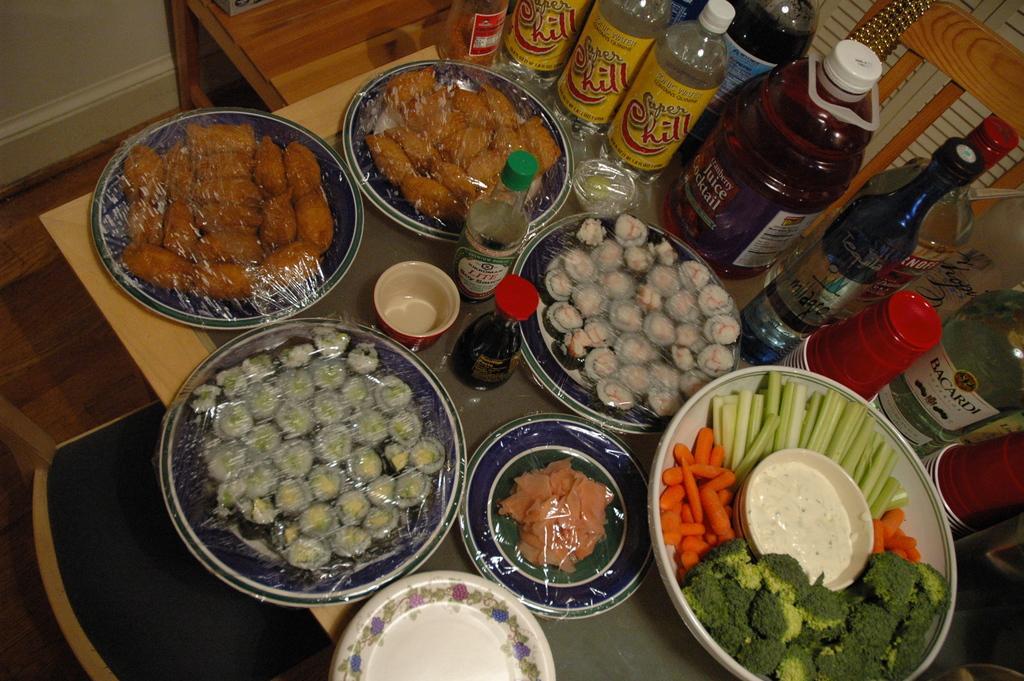In one or two sentences, can you explain what this image depicts? In this image I can see a table , on the table I can see few plates and bottles and top of plates I can see food items and vegetables and some food item kept and in the top right I can see a chair 